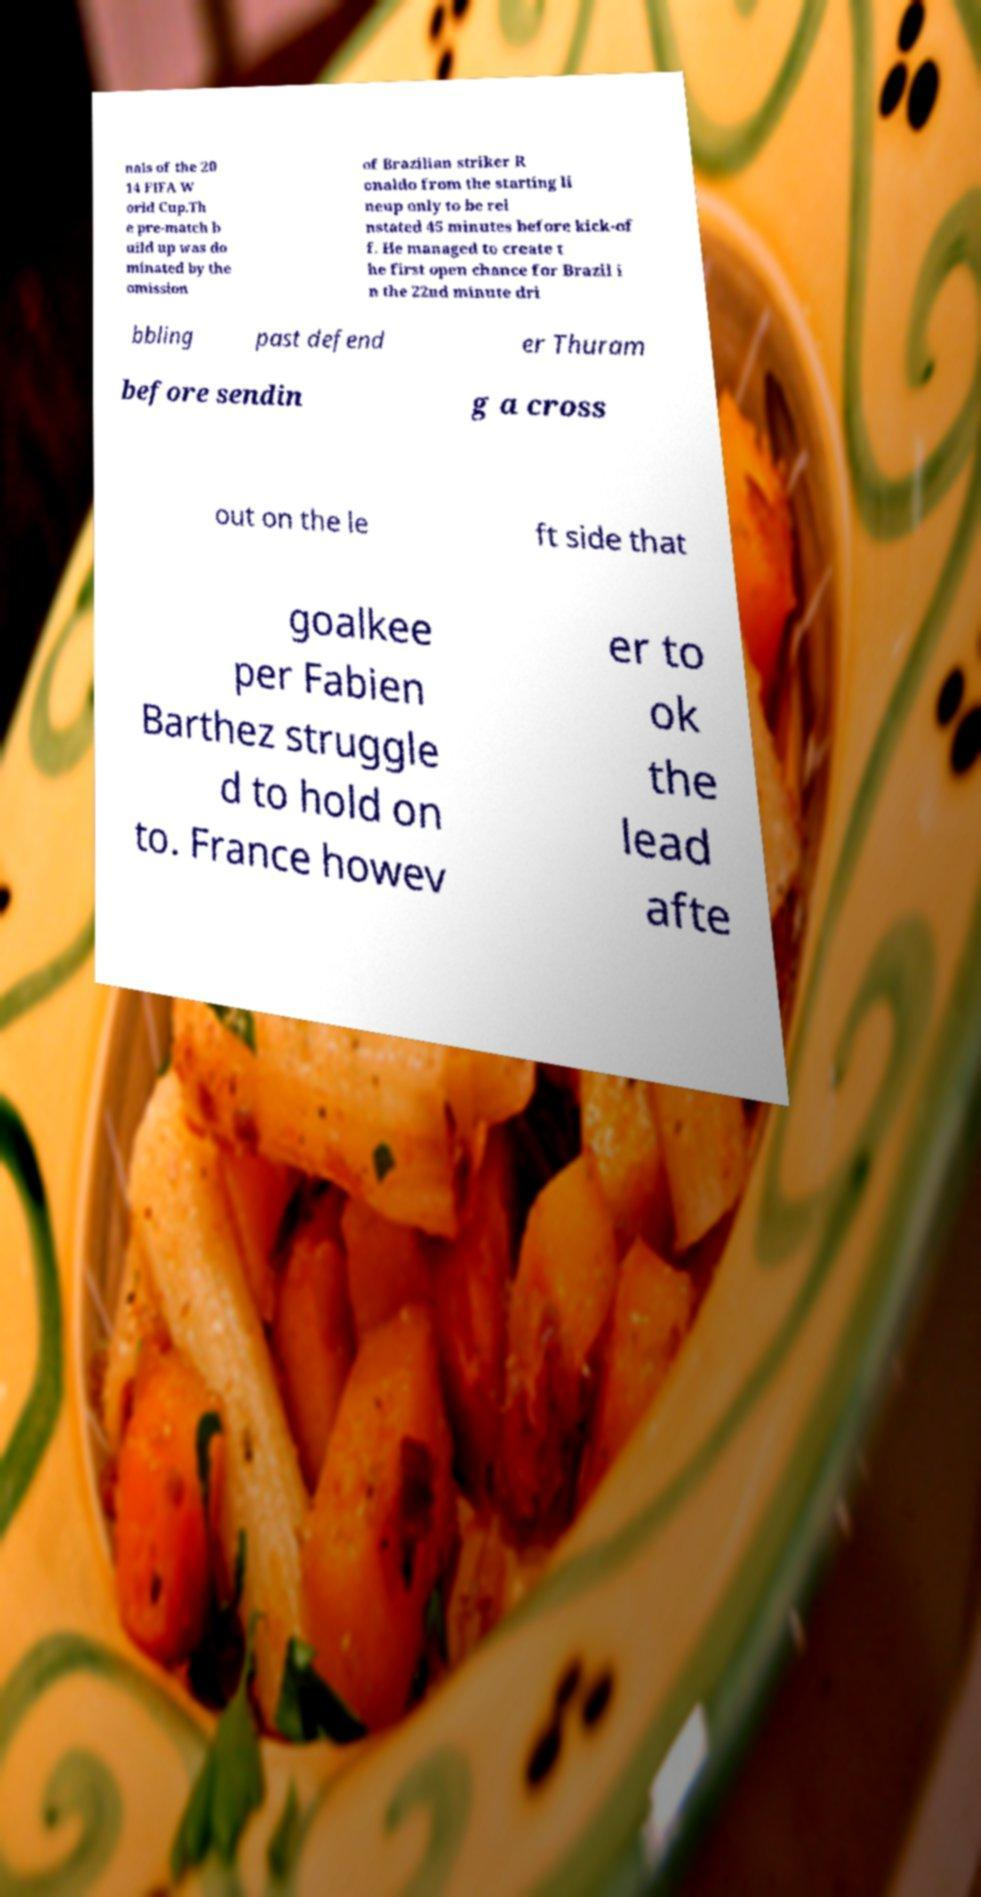What messages or text are displayed in this image? I need them in a readable, typed format. nals of the 20 14 FIFA W orld Cup.Th e pre-match b uild up was do minated by the omission of Brazilian striker R onaldo from the starting li neup only to be rei nstated 45 minutes before kick-of f. He managed to create t he first open chance for Brazil i n the 22nd minute dri bbling past defend er Thuram before sendin g a cross out on the le ft side that goalkee per Fabien Barthez struggle d to hold on to. France howev er to ok the lead afte 